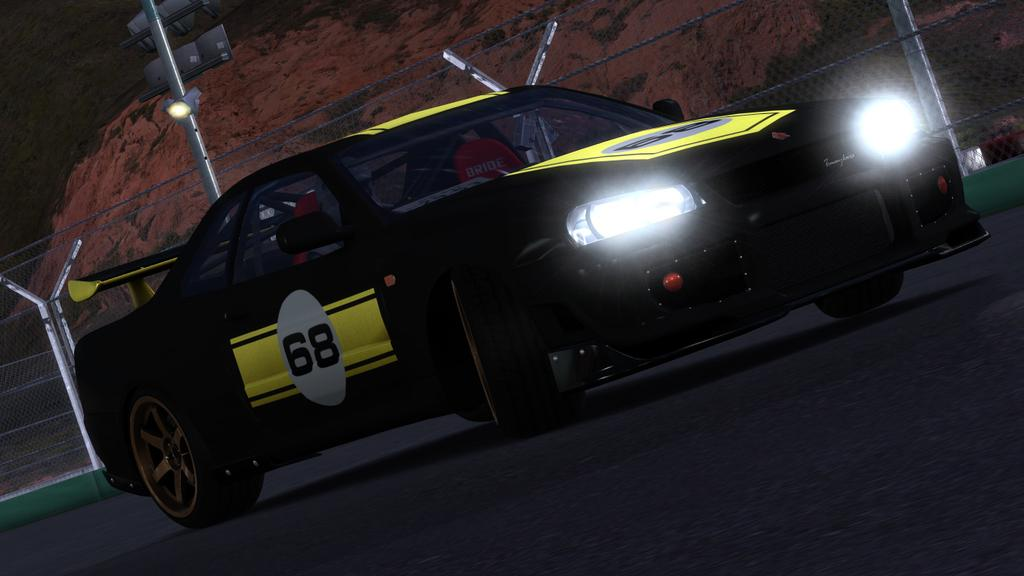What is the main subject of the image? There is a car in the image. Where is the car located? The car is on the road. What can be seen in the background of the image? There is a mesh, a pole, and a hill in the background of the image. What type of card is the aunt holding in the image? There is no card or aunt present in the image; it features a car on the road with a background containing a mesh, pole, and hill. 